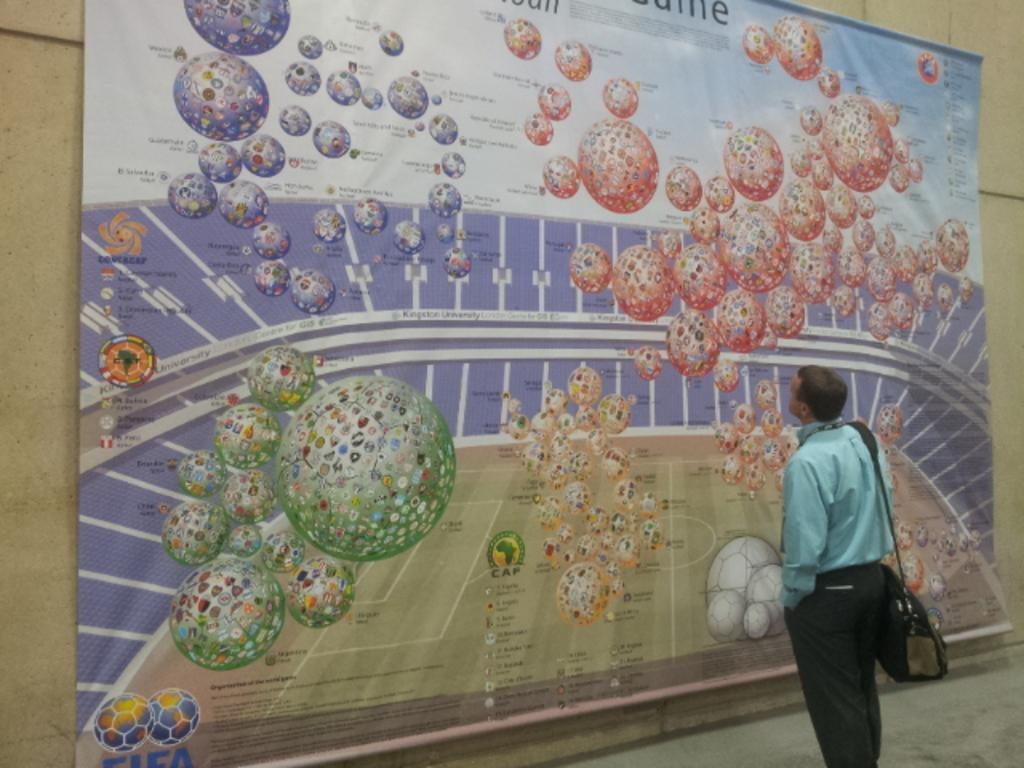Who is present in the image? There is a man in the image. What is the man wearing? The man is wearing a sea green shirt. What is the man holding in the image? The man is holding a bag. What is the man's posture in the image? The man is standing. What is the man looking at in the image? The man is looking at a banner. What is the background of the image? There is a wall in the image. What type of jelly is the man eating in the image? There is no jelly present in the image, and no indication that the man is eating anything. 